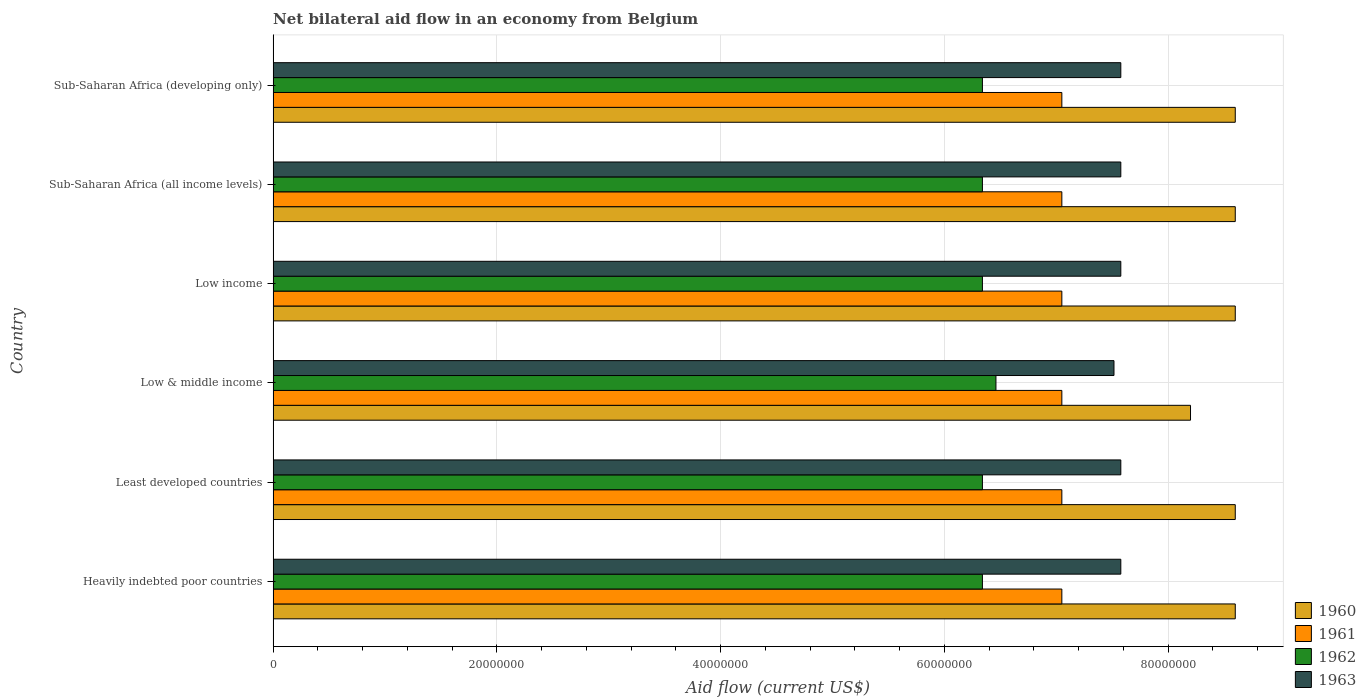How many groups of bars are there?
Your response must be concise. 6. Are the number of bars per tick equal to the number of legend labels?
Your answer should be very brief. Yes. How many bars are there on the 1st tick from the top?
Provide a succinct answer. 4. How many bars are there on the 2nd tick from the bottom?
Provide a succinct answer. 4. What is the label of the 1st group of bars from the top?
Provide a succinct answer. Sub-Saharan Africa (developing only). In how many cases, is the number of bars for a given country not equal to the number of legend labels?
Make the answer very short. 0. What is the net bilateral aid flow in 1960 in Low & middle income?
Your answer should be very brief. 8.20e+07. Across all countries, what is the maximum net bilateral aid flow in 1961?
Provide a succinct answer. 7.05e+07. Across all countries, what is the minimum net bilateral aid flow in 1960?
Offer a very short reply. 8.20e+07. In which country was the net bilateral aid flow in 1963 maximum?
Your answer should be compact. Heavily indebted poor countries. In which country was the net bilateral aid flow in 1961 minimum?
Your response must be concise. Heavily indebted poor countries. What is the total net bilateral aid flow in 1960 in the graph?
Provide a short and direct response. 5.12e+08. What is the difference between the net bilateral aid flow in 1961 in Heavily indebted poor countries and the net bilateral aid flow in 1963 in Least developed countries?
Keep it short and to the point. -5.27e+06. What is the average net bilateral aid flow in 1962 per country?
Offer a terse response. 6.36e+07. What is the difference between the net bilateral aid flow in 1962 and net bilateral aid flow in 1960 in Heavily indebted poor countries?
Provide a short and direct response. -2.26e+07. What is the difference between the highest and the lowest net bilateral aid flow in 1961?
Your response must be concise. 0. Is the sum of the net bilateral aid flow in 1962 in Least developed countries and Sub-Saharan Africa (developing only) greater than the maximum net bilateral aid flow in 1960 across all countries?
Your answer should be very brief. Yes. What does the 4th bar from the bottom in Low income represents?
Your answer should be very brief. 1963. Is it the case that in every country, the sum of the net bilateral aid flow in 1961 and net bilateral aid flow in 1962 is greater than the net bilateral aid flow in 1963?
Offer a very short reply. Yes. How many bars are there?
Your answer should be very brief. 24. How many countries are there in the graph?
Provide a short and direct response. 6. Does the graph contain any zero values?
Offer a terse response. No. How many legend labels are there?
Make the answer very short. 4. How are the legend labels stacked?
Your answer should be very brief. Vertical. What is the title of the graph?
Offer a terse response. Net bilateral aid flow in an economy from Belgium. Does "1967" appear as one of the legend labels in the graph?
Your answer should be compact. No. What is the label or title of the Y-axis?
Offer a terse response. Country. What is the Aid flow (current US$) in 1960 in Heavily indebted poor countries?
Your answer should be compact. 8.60e+07. What is the Aid flow (current US$) of 1961 in Heavily indebted poor countries?
Offer a terse response. 7.05e+07. What is the Aid flow (current US$) in 1962 in Heavily indebted poor countries?
Offer a very short reply. 6.34e+07. What is the Aid flow (current US$) of 1963 in Heavily indebted poor countries?
Provide a succinct answer. 7.58e+07. What is the Aid flow (current US$) in 1960 in Least developed countries?
Your answer should be compact. 8.60e+07. What is the Aid flow (current US$) of 1961 in Least developed countries?
Provide a succinct answer. 7.05e+07. What is the Aid flow (current US$) in 1962 in Least developed countries?
Ensure brevity in your answer.  6.34e+07. What is the Aid flow (current US$) in 1963 in Least developed countries?
Your answer should be very brief. 7.58e+07. What is the Aid flow (current US$) in 1960 in Low & middle income?
Ensure brevity in your answer.  8.20e+07. What is the Aid flow (current US$) of 1961 in Low & middle income?
Offer a very short reply. 7.05e+07. What is the Aid flow (current US$) of 1962 in Low & middle income?
Your response must be concise. 6.46e+07. What is the Aid flow (current US$) in 1963 in Low & middle income?
Offer a terse response. 7.52e+07. What is the Aid flow (current US$) of 1960 in Low income?
Make the answer very short. 8.60e+07. What is the Aid flow (current US$) of 1961 in Low income?
Make the answer very short. 7.05e+07. What is the Aid flow (current US$) of 1962 in Low income?
Ensure brevity in your answer.  6.34e+07. What is the Aid flow (current US$) in 1963 in Low income?
Give a very brief answer. 7.58e+07. What is the Aid flow (current US$) in 1960 in Sub-Saharan Africa (all income levels)?
Your answer should be compact. 8.60e+07. What is the Aid flow (current US$) of 1961 in Sub-Saharan Africa (all income levels)?
Offer a very short reply. 7.05e+07. What is the Aid flow (current US$) of 1962 in Sub-Saharan Africa (all income levels)?
Your answer should be very brief. 6.34e+07. What is the Aid flow (current US$) of 1963 in Sub-Saharan Africa (all income levels)?
Provide a short and direct response. 7.58e+07. What is the Aid flow (current US$) of 1960 in Sub-Saharan Africa (developing only)?
Your answer should be compact. 8.60e+07. What is the Aid flow (current US$) in 1961 in Sub-Saharan Africa (developing only)?
Provide a succinct answer. 7.05e+07. What is the Aid flow (current US$) in 1962 in Sub-Saharan Africa (developing only)?
Your answer should be compact. 6.34e+07. What is the Aid flow (current US$) in 1963 in Sub-Saharan Africa (developing only)?
Offer a very short reply. 7.58e+07. Across all countries, what is the maximum Aid flow (current US$) of 1960?
Provide a succinct answer. 8.60e+07. Across all countries, what is the maximum Aid flow (current US$) in 1961?
Keep it short and to the point. 7.05e+07. Across all countries, what is the maximum Aid flow (current US$) in 1962?
Make the answer very short. 6.46e+07. Across all countries, what is the maximum Aid flow (current US$) in 1963?
Offer a terse response. 7.58e+07. Across all countries, what is the minimum Aid flow (current US$) in 1960?
Provide a short and direct response. 8.20e+07. Across all countries, what is the minimum Aid flow (current US$) in 1961?
Provide a succinct answer. 7.05e+07. Across all countries, what is the minimum Aid flow (current US$) in 1962?
Your response must be concise. 6.34e+07. Across all countries, what is the minimum Aid flow (current US$) of 1963?
Offer a terse response. 7.52e+07. What is the total Aid flow (current US$) in 1960 in the graph?
Your answer should be compact. 5.12e+08. What is the total Aid flow (current US$) of 1961 in the graph?
Give a very brief answer. 4.23e+08. What is the total Aid flow (current US$) in 1962 in the graph?
Provide a short and direct response. 3.82e+08. What is the total Aid flow (current US$) in 1963 in the graph?
Provide a short and direct response. 4.54e+08. What is the difference between the Aid flow (current US$) of 1960 in Heavily indebted poor countries and that in Least developed countries?
Offer a very short reply. 0. What is the difference between the Aid flow (current US$) in 1962 in Heavily indebted poor countries and that in Least developed countries?
Provide a short and direct response. 0. What is the difference between the Aid flow (current US$) of 1961 in Heavily indebted poor countries and that in Low & middle income?
Your answer should be compact. 0. What is the difference between the Aid flow (current US$) in 1962 in Heavily indebted poor countries and that in Low & middle income?
Ensure brevity in your answer.  -1.21e+06. What is the difference between the Aid flow (current US$) in 1960 in Heavily indebted poor countries and that in Low income?
Your answer should be compact. 0. What is the difference between the Aid flow (current US$) of 1960 in Heavily indebted poor countries and that in Sub-Saharan Africa (all income levels)?
Make the answer very short. 0. What is the difference between the Aid flow (current US$) in 1961 in Heavily indebted poor countries and that in Sub-Saharan Africa (all income levels)?
Your answer should be very brief. 0. What is the difference between the Aid flow (current US$) in 1960 in Heavily indebted poor countries and that in Sub-Saharan Africa (developing only)?
Give a very brief answer. 0. What is the difference between the Aid flow (current US$) of 1962 in Heavily indebted poor countries and that in Sub-Saharan Africa (developing only)?
Make the answer very short. 0. What is the difference between the Aid flow (current US$) in 1963 in Heavily indebted poor countries and that in Sub-Saharan Africa (developing only)?
Your response must be concise. 0. What is the difference between the Aid flow (current US$) of 1962 in Least developed countries and that in Low & middle income?
Provide a succinct answer. -1.21e+06. What is the difference between the Aid flow (current US$) in 1963 in Least developed countries and that in Low & middle income?
Provide a short and direct response. 6.10e+05. What is the difference between the Aid flow (current US$) in 1963 in Least developed countries and that in Low income?
Ensure brevity in your answer.  0. What is the difference between the Aid flow (current US$) in 1960 in Least developed countries and that in Sub-Saharan Africa (all income levels)?
Offer a terse response. 0. What is the difference between the Aid flow (current US$) in 1961 in Least developed countries and that in Sub-Saharan Africa (all income levels)?
Ensure brevity in your answer.  0. What is the difference between the Aid flow (current US$) of 1963 in Least developed countries and that in Sub-Saharan Africa (all income levels)?
Give a very brief answer. 0. What is the difference between the Aid flow (current US$) of 1961 in Least developed countries and that in Sub-Saharan Africa (developing only)?
Provide a succinct answer. 0. What is the difference between the Aid flow (current US$) in 1962 in Least developed countries and that in Sub-Saharan Africa (developing only)?
Provide a succinct answer. 0. What is the difference between the Aid flow (current US$) in 1963 in Least developed countries and that in Sub-Saharan Africa (developing only)?
Provide a short and direct response. 0. What is the difference between the Aid flow (current US$) in 1960 in Low & middle income and that in Low income?
Offer a terse response. -4.00e+06. What is the difference between the Aid flow (current US$) of 1961 in Low & middle income and that in Low income?
Keep it short and to the point. 0. What is the difference between the Aid flow (current US$) of 1962 in Low & middle income and that in Low income?
Offer a very short reply. 1.21e+06. What is the difference between the Aid flow (current US$) of 1963 in Low & middle income and that in Low income?
Offer a very short reply. -6.10e+05. What is the difference between the Aid flow (current US$) in 1960 in Low & middle income and that in Sub-Saharan Africa (all income levels)?
Provide a short and direct response. -4.00e+06. What is the difference between the Aid flow (current US$) in 1961 in Low & middle income and that in Sub-Saharan Africa (all income levels)?
Keep it short and to the point. 0. What is the difference between the Aid flow (current US$) in 1962 in Low & middle income and that in Sub-Saharan Africa (all income levels)?
Ensure brevity in your answer.  1.21e+06. What is the difference between the Aid flow (current US$) in 1963 in Low & middle income and that in Sub-Saharan Africa (all income levels)?
Your answer should be compact. -6.10e+05. What is the difference between the Aid flow (current US$) in 1960 in Low & middle income and that in Sub-Saharan Africa (developing only)?
Provide a succinct answer. -4.00e+06. What is the difference between the Aid flow (current US$) in 1961 in Low & middle income and that in Sub-Saharan Africa (developing only)?
Give a very brief answer. 0. What is the difference between the Aid flow (current US$) of 1962 in Low & middle income and that in Sub-Saharan Africa (developing only)?
Give a very brief answer. 1.21e+06. What is the difference between the Aid flow (current US$) in 1963 in Low & middle income and that in Sub-Saharan Africa (developing only)?
Provide a short and direct response. -6.10e+05. What is the difference between the Aid flow (current US$) of 1960 in Low income and that in Sub-Saharan Africa (all income levels)?
Provide a short and direct response. 0. What is the difference between the Aid flow (current US$) of 1961 in Low income and that in Sub-Saharan Africa (all income levels)?
Offer a very short reply. 0. What is the difference between the Aid flow (current US$) in 1961 in Low income and that in Sub-Saharan Africa (developing only)?
Ensure brevity in your answer.  0. What is the difference between the Aid flow (current US$) in 1962 in Low income and that in Sub-Saharan Africa (developing only)?
Make the answer very short. 0. What is the difference between the Aid flow (current US$) in 1963 in Low income and that in Sub-Saharan Africa (developing only)?
Your answer should be compact. 0. What is the difference between the Aid flow (current US$) in 1960 in Sub-Saharan Africa (all income levels) and that in Sub-Saharan Africa (developing only)?
Your answer should be compact. 0. What is the difference between the Aid flow (current US$) in 1961 in Sub-Saharan Africa (all income levels) and that in Sub-Saharan Africa (developing only)?
Provide a short and direct response. 0. What is the difference between the Aid flow (current US$) of 1963 in Sub-Saharan Africa (all income levels) and that in Sub-Saharan Africa (developing only)?
Your answer should be very brief. 0. What is the difference between the Aid flow (current US$) in 1960 in Heavily indebted poor countries and the Aid flow (current US$) in 1961 in Least developed countries?
Offer a very short reply. 1.55e+07. What is the difference between the Aid flow (current US$) in 1960 in Heavily indebted poor countries and the Aid flow (current US$) in 1962 in Least developed countries?
Offer a very short reply. 2.26e+07. What is the difference between the Aid flow (current US$) of 1960 in Heavily indebted poor countries and the Aid flow (current US$) of 1963 in Least developed countries?
Keep it short and to the point. 1.02e+07. What is the difference between the Aid flow (current US$) in 1961 in Heavily indebted poor countries and the Aid flow (current US$) in 1962 in Least developed countries?
Your answer should be very brief. 7.10e+06. What is the difference between the Aid flow (current US$) in 1961 in Heavily indebted poor countries and the Aid flow (current US$) in 1963 in Least developed countries?
Provide a succinct answer. -5.27e+06. What is the difference between the Aid flow (current US$) of 1962 in Heavily indebted poor countries and the Aid flow (current US$) of 1963 in Least developed countries?
Provide a short and direct response. -1.24e+07. What is the difference between the Aid flow (current US$) of 1960 in Heavily indebted poor countries and the Aid flow (current US$) of 1961 in Low & middle income?
Your answer should be very brief. 1.55e+07. What is the difference between the Aid flow (current US$) of 1960 in Heavily indebted poor countries and the Aid flow (current US$) of 1962 in Low & middle income?
Make the answer very short. 2.14e+07. What is the difference between the Aid flow (current US$) in 1960 in Heavily indebted poor countries and the Aid flow (current US$) in 1963 in Low & middle income?
Offer a terse response. 1.08e+07. What is the difference between the Aid flow (current US$) of 1961 in Heavily indebted poor countries and the Aid flow (current US$) of 1962 in Low & middle income?
Your answer should be compact. 5.89e+06. What is the difference between the Aid flow (current US$) in 1961 in Heavily indebted poor countries and the Aid flow (current US$) in 1963 in Low & middle income?
Make the answer very short. -4.66e+06. What is the difference between the Aid flow (current US$) of 1962 in Heavily indebted poor countries and the Aid flow (current US$) of 1963 in Low & middle income?
Your answer should be compact. -1.18e+07. What is the difference between the Aid flow (current US$) of 1960 in Heavily indebted poor countries and the Aid flow (current US$) of 1961 in Low income?
Offer a terse response. 1.55e+07. What is the difference between the Aid flow (current US$) in 1960 in Heavily indebted poor countries and the Aid flow (current US$) in 1962 in Low income?
Give a very brief answer. 2.26e+07. What is the difference between the Aid flow (current US$) of 1960 in Heavily indebted poor countries and the Aid flow (current US$) of 1963 in Low income?
Offer a terse response. 1.02e+07. What is the difference between the Aid flow (current US$) in 1961 in Heavily indebted poor countries and the Aid flow (current US$) in 1962 in Low income?
Make the answer very short. 7.10e+06. What is the difference between the Aid flow (current US$) of 1961 in Heavily indebted poor countries and the Aid flow (current US$) of 1963 in Low income?
Your answer should be very brief. -5.27e+06. What is the difference between the Aid flow (current US$) of 1962 in Heavily indebted poor countries and the Aid flow (current US$) of 1963 in Low income?
Keep it short and to the point. -1.24e+07. What is the difference between the Aid flow (current US$) in 1960 in Heavily indebted poor countries and the Aid flow (current US$) in 1961 in Sub-Saharan Africa (all income levels)?
Offer a very short reply. 1.55e+07. What is the difference between the Aid flow (current US$) of 1960 in Heavily indebted poor countries and the Aid flow (current US$) of 1962 in Sub-Saharan Africa (all income levels)?
Keep it short and to the point. 2.26e+07. What is the difference between the Aid flow (current US$) of 1960 in Heavily indebted poor countries and the Aid flow (current US$) of 1963 in Sub-Saharan Africa (all income levels)?
Ensure brevity in your answer.  1.02e+07. What is the difference between the Aid flow (current US$) of 1961 in Heavily indebted poor countries and the Aid flow (current US$) of 1962 in Sub-Saharan Africa (all income levels)?
Make the answer very short. 7.10e+06. What is the difference between the Aid flow (current US$) in 1961 in Heavily indebted poor countries and the Aid flow (current US$) in 1963 in Sub-Saharan Africa (all income levels)?
Give a very brief answer. -5.27e+06. What is the difference between the Aid flow (current US$) of 1962 in Heavily indebted poor countries and the Aid flow (current US$) of 1963 in Sub-Saharan Africa (all income levels)?
Your response must be concise. -1.24e+07. What is the difference between the Aid flow (current US$) of 1960 in Heavily indebted poor countries and the Aid flow (current US$) of 1961 in Sub-Saharan Africa (developing only)?
Make the answer very short. 1.55e+07. What is the difference between the Aid flow (current US$) of 1960 in Heavily indebted poor countries and the Aid flow (current US$) of 1962 in Sub-Saharan Africa (developing only)?
Your answer should be very brief. 2.26e+07. What is the difference between the Aid flow (current US$) in 1960 in Heavily indebted poor countries and the Aid flow (current US$) in 1963 in Sub-Saharan Africa (developing only)?
Make the answer very short. 1.02e+07. What is the difference between the Aid flow (current US$) of 1961 in Heavily indebted poor countries and the Aid flow (current US$) of 1962 in Sub-Saharan Africa (developing only)?
Your answer should be compact. 7.10e+06. What is the difference between the Aid flow (current US$) of 1961 in Heavily indebted poor countries and the Aid flow (current US$) of 1963 in Sub-Saharan Africa (developing only)?
Provide a succinct answer. -5.27e+06. What is the difference between the Aid flow (current US$) in 1962 in Heavily indebted poor countries and the Aid flow (current US$) in 1963 in Sub-Saharan Africa (developing only)?
Ensure brevity in your answer.  -1.24e+07. What is the difference between the Aid flow (current US$) of 1960 in Least developed countries and the Aid flow (current US$) of 1961 in Low & middle income?
Provide a succinct answer. 1.55e+07. What is the difference between the Aid flow (current US$) in 1960 in Least developed countries and the Aid flow (current US$) in 1962 in Low & middle income?
Ensure brevity in your answer.  2.14e+07. What is the difference between the Aid flow (current US$) of 1960 in Least developed countries and the Aid flow (current US$) of 1963 in Low & middle income?
Keep it short and to the point. 1.08e+07. What is the difference between the Aid flow (current US$) in 1961 in Least developed countries and the Aid flow (current US$) in 1962 in Low & middle income?
Offer a terse response. 5.89e+06. What is the difference between the Aid flow (current US$) in 1961 in Least developed countries and the Aid flow (current US$) in 1963 in Low & middle income?
Ensure brevity in your answer.  -4.66e+06. What is the difference between the Aid flow (current US$) of 1962 in Least developed countries and the Aid flow (current US$) of 1963 in Low & middle income?
Keep it short and to the point. -1.18e+07. What is the difference between the Aid flow (current US$) of 1960 in Least developed countries and the Aid flow (current US$) of 1961 in Low income?
Ensure brevity in your answer.  1.55e+07. What is the difference between the Aid flow (current US$) of 1960 in Least developed countries and the Aid flow (current US$) of 1962 in Low income?
Provide a short and direct response. 2.26e+07. What is the difference between the Aid flow (current US$) in 1960 in Least developed countries and the Aid flow (current US$) in 1963 in Low income?
Your response must be concise. 1.02e+07. What is the difference between the Aid flow (current US$) in 1961 in Least developed countries and the Aid flow (current US$) in 1962 in Low income?
Keep it short and to the point. 7.10e+06. What is the difference between the Aid flow (current US$) of 1961 in Least developed countries and the Aid flow (current US$) of 1963 in Low income?
Your response must be concise. -5.27e+06. What is the difference between the Aid flow (current US$) in 1962 in Least developed countries and the Aid flow (current US$) in 1963 in Low income?
Make the answer very short. -1.24e+07. What is the difference between the Aid flow (current US$) in 1960 in Least developed countries and the Aid flow (current US$) in 1961 in Sub-Saharan Africa (all income levels)?
Keep it short and to the point. 1.55e+07. What is the difference between the Aid flow (current US$) in 1960 in Least developed countries and the Aid flow (current US$) in 1962 in Sub-Saharan Africa (all income levels)?
Ensure brevity in your answer.  2.26e+07. What is the difference between the Aid flow (current US$) in 1960 in Least developed countries and the Aid flow (current US$) in 1963 in Sub-Saharan Africa (all income levels)?
Provide a succinct answer. 1.02e+07. What is the difference between the Aid flow (current US$) in 1961 in Least developed countries and the Aid flow (current US$) in 1962 in Sub-Saharan Africa (all income levels)?
Offer a very short reply. 7.10e+06. What is the difference between the Aid flow (current US$) of 1961 in Least developed countries and the Aid flow (current US$) of 1963 in Sub-Saharan Africa (all income levels)?
Offer a terse response. -5.27e+06. What is the difference between the Aid flow (current US$) in 1962 in Least developed countries and the Aid flow (current US$) in 1963 in Sub-Saharan Africa (all income levels)?
Offer a terse response. -1.24e+07. What is the difference between the Aid flow (current US$) of 1960 in Least developed countries and the Aid flow (current US$) of 1961 in Sub-Saharan Africa (developing only)?
Ensure brevity in your answer.  1.55e+07. What is the difference between the Aid flow (current US$) in 1960 in Least developed countries and the Aid flow (current US$) in 1962 in Sub-Saharan Africa (developing only)?
Your answer should be very brief. 2.26e+07. What is the difference between the Aid flow (current US$) in 1960 in Least developed countries and the Aid flow (current US$) in 1963 in Sub-Saharan Africa (developing only)?
Provide a succinct answer. 1.02e+07. What is the difference between the Aid flow (current US$) of 1961 in Least developed countries and the Aid flow (current US$) of 1962 in Sub-Saharan Africa (developing only)?
Provide a succinct answer. 7.10e+06. What is the difference between the Aid flow (current US$) in 1961 in Least developed countries and the Aid flow (current US$) in 1963 in Sub-Saharan Africa (developing only)?
Your response must be concise. -5.27e+06. What is the difference between the Aid flow (current US$) of 1962 in Least developed countries and the Aid flow (current US$) of 1963 in Sub-Saharan Africa (developing only)?
Provide a succinct answer. -1.24e+07. What is the difference between the Aid flow (current US$) of 1960 in Low & middle income and the Aid flow (current US$) of 1961 in Low income?
Make the answer very short. 1.15e+07. What is the difference between the Aid flow (current US$) in 1960 in Low & middle income and the Aid flow (current US$) in 1962 in Low income?
Provide a succinct answer. 1.86e+07. What is the difference between the Aid flow (current US$) in 1960 in Low & middle income and the Aid flow (current US$) in 1963 in Low income?
Your response must be concise. 6.23e+06. What is the difference between the Aid flow (current US$) of 1961 in Low & middle income and the Aid flow (current US$) of 1962 in Low income?
Ensure brevity in your answer.  7.10e+06. What is the difference between the Aid flow (current US$) of 1961 in Low & middle income and the Aid flow (current US$) of 1963 in Low income?
Provide a short and direct response. -5.27e+06. What is the difference between the Aid flow (current US$) of 1962 in Low & middle income and the Aid flow (current US$) of 1963 in Low income?
Make the answer very short. -1.12e+07. What is the difference between the Aid flow (current US$) of 1960 in Low & middle income and the Aid flow (current US$) of 1961 in Sub-Saharan Africa (all income levels)?
Provide a succinct answer. 1.15e+07. What is the difference between the Aid flow (current US$) of 1960 in Low & middle income and the Aid flow (current US$) of 1962 in Sub-Saharan Africa (all income levels)?
Your response must be concise. 1.86e+07. What is the difference between the Aid flow (current US$) in 1960 in Low & middle income and the Aid flow (current US$) in 1963 in Sub-Saharan Africa (all income levels)?
Give a very brief answer. 6.23e+06. What is the difference between the Aid flow (current US$) of 1961 in Low & middle income and the Aid flow (current US$) of 1962 in Sub-Saharan Africa (all income levels)?
Offer a very short reply. 7.10e+06. What is the difference between the Aid flow (current US$) in 1961 in Low & middle income and the Aid flow (current US$) in 1963 in Sub-Saharan Africa (all income levels)?
Your answer should be very brief. -5.27e+06. What is the difference between the Aid flow (current US$) in 1962 in Low & middle income and the Aid flow (current US$) in 1963 in Sub-Saharan Africa (all income levels)?
Your answer should be compact. -1.12e+07. What is the difference between the Aid flow (current US$) in 1960 in Low & middle income and the Aid flow (current US$) in 1961 in Sub-Saharan Africa (developing only)?
Provide a succinct answer. 1.15e+07. What is the difference between the Aid flow (current US$) in 1960 in Low & middle income and the Aid flow (current US$) in 1962 in Sub-Saharan Africa (developing only)?
Give a very brief answer. 1.86e+07. What is the difference between the Aid flow (current US$) in 1960 in Low & middle income and the Aid flow (current US$) in 1963 in Sub-Saharan Africa (developing only)?
Offer a very short reply. 6.23e+06. What is the difference between the Aid flow (current US$) in 1961 in Low & middle income and the Aid flow (current US$) in 1962 in Sub-Saharan Africa (developing only)?
Offer a terse response. 7.10e+06. What is the difference between the Aid flow (current US$) in 1961 in Low & middle income and the Aid flow (current US$) in 1963 in Sub-Saharan Africa (developing only)?
Your answer should be very brief. -5.27e+06. What is the difference between the Aid flow (current US$) of 1962 in Low & middle income and the Aid flow (current US$) of 1963 in Sub-Saharan Africa (developing only)?
Provide a short and direct response. -1.12e+07. What is the difference between the Aid flow (current US$) in 1960 in Low income and the Aid flow (current US$) in 1961 in Sub-Saharan Africa (all income levels)?
Your answer should be compact. 1.55e+07. What is the difference between the Aid flow (current US$) of 1960 in Low income and the Aid flow (current US$) of 1962 in Sub-Saharan Africa (all income levels)?
Offer a terse response. 2.26e+07. What is the difference between the Aid flow (current US$) in 1960 in Low income and the Aid flow (current US$) in 1963 in Sub-Saharan Africa (all income levels)?
Offer a terse response. 1.02e+07. What is the difference between the Aid flow (current US$) in 1961 in Low income and the Aid flow (current US$) in 1962 in Sub-Saharan Africa (all income levels)?
Offer a very short reply. 7.10e+06. What is the difference between the Aid flow (current US$) of 1961 in Low income and the Aid flow (current US$) of 1963 in Sub-Saharan Africa (all income levels)?
Give a very brief answer. -5.27e+06. What is the difference between the Aid flow (current US$) of 1962 in Low income and the Aid flow (current US$) of 1963 in Sub-Saharan Africa (all income levels)?
Your answer should be very brief. -1.24e+07. What is the difference between the Aid flow (current US$) in 1960 in Low income and the Aid flow (current US$) in 1961 in Sub-Saharan Africa (developing only)?
Give a very brief answer. 1.55e+07. What is the difference between the Aid flow (current US$) of 1960 in Low income and the Aid flow (current US$) of 1962 in Sub-Saharan Africa (developing only)?
Keep it short and to the point. 2.26e+07. What is the difference between the Aid flow (current US$) of 1960 in Low income and the Aid flow (current US$) of 1963 in Sub-Saharan Africa (developing only)?
Your answer should be compact. 1.02e+07. What is the difference between the Aid flow (current US$) of 1961 in Low income and the Aid flow (current US$) of 1962 in Sub-Saharan Africa (developing only)?
Offer a terse response. 7.10e+06. What is the difference between the Aid flow (current US$) of 1961 in Low income and the Aid flow (current US$) of 1963 in Sub-Saharan Africa (developing only)?
Ensure brevity in your answer.  -5.27e+06. What is the difference between the Aid flow (current US$) in 1962 in Low income and the Aid flow (current US$) in 1963 in Sub-Saharan Africa (developing only)?
Offer a terse response. -1.24e+07. What is the difference between the Aid flow (current US$) of 1960 in Sub-Saharan Africa (all income levels) and the Aid flow (current US$) of 1961 in Sub-Saharan Africa (developing only)?
Ensure brevity in your answer.  1.55e+07. What is the difference between the Aid flow (current US$) in 1960 in Sub-Saharan Africa (all income levels) and the Aid flow (current US$) in 1962 in Sub-Saharan Africa (developing only)?
Provide a short and direct response. 2.26e+07. What is the difference between the Aid flow (current US$) in 1960 in Sub-Saharan Africa (all income levels) and the Aid flow (current US$) in 1963 in Sub-Saharan Africa (developing only)?
Keep it short and to the point. 1.02e+07. What is the difference between the Aid flow (current US$) in 1961 in Sub-Saharan Africa (all income levels) and the Aid flow (current US$) in 1962 in Sub-Saharan Africa (developing only)?
Ensure brevity in your answer.  7.10e+06. What is the difference between the Aid flow (current US$) in 1961 in Sub-Saharan Africa (all income levels) and the Aid flow (current US$) in 1963 in Sub-Saharan Africa (developing only)?
Provide a succinct answer. -5.27e+06. What is the difference between the Aid flow (current US$) in 1962 in Sub-Saharan Africa (all income levels) and the Aid flow (current US$) in 1963 in Sub-Saharan Africa (developing only)?
Offer a very short reply. -1.24e+07. What is the average Aid flow (current US$) of 1960 per country?
Offer a very short reply. 8.53e+07. What is the average Aid flow (current US$) of 1961 per country?
Keep it short and to the point. 7.05e+07. What is the average Aid flow (current US$) of 1962 per country?
Give a very brief answer. 6.36e+07. What is the average Aid flow (current US$) in 1963 per country?
Ensure brevity in your answer.  7.57e+07. What is the difference between the Aid flow (current US$) in 1960 and Aid flow (current US$) in 1961 in Heavily indebted poor countries?
Provide a short and direct response. 1.55e+07. What is the difference between the Aid flow (current US$) in 1960 and Aid flow (current US$) in 1962 in Heavily indebted poor countries?
Your answer should be very brief. 2.26e+07. What is the difference between the Aid flow (current US$) in 1960 and Aid flow (current US$) in 1963 in Heavily indebted poor countries?
Ensure brevity in your answer.  1.02e+07. What is the difference between the Aid flow (current US$) in 1961 and Aid flow (current US$) in 1962 in Heavily indebted poor countries?
Give a very brief answer. 7.10e+06. What is the difference between the Aid flow (current US$) of 1961 and Aid flow (current US$) of 1963 in Heavily indebted poor countries?
Ensure brevity in your answer.  -5.27e+06. What is the difference between the Aid flow (current US$) of 1962 and Aid flow (current US$) of 1963 in Heavily indebted poor countries?
Offer a terse response. -1.24e+07. What is the difference between the Aid flow (current US$) in 1960 and Aid flow (current US$) in 1961 in Least developed countries?
Offer a very short reply. 1.55e+07. What is the difference between the Aid flow (current US$) in 1960 and Aid flow (current US$) in 1962 in Least developed countries?
Provide a short and direct response. 2.26e+07. What is the difference between the Aid flow (current US$) of 1960 and Aid flow (current US$) of 1963 in Least developed countries?
Make the answer very short. 1.02e+07. What is the difference between the Aid flow (current US$) in 1961 and Aid flow (current US$) in 1962 in Least developed countries?
Give a very brief answer. 7.10e+06. What is the difference between the Aid flow (current US$) of 1961 and Aid flow (current US$) of 1963 in Least developed countries?
Your response must be concise. -5.27e+06. What is the difference between the Aid flow (current US$) of 1962 and Aid flow (current US$) of 1963 in Least developed countries?
Provide a short and direct response. -1.24e+07. What is the difference between the Aid flow (current US$) of 1960 and Aid flow (current US$) of 1961 in Low & middle income?
Provide a short and direct response. 1.15e+07. What is the difference between the Aid flow (current US$) of 1960 and Aid flow (current US$) of 1962 in Low & middle income?
Your answer should be compact. 1.74e+07. What is the difference between the Aid flow (current US$) in 1960 and Aid flow (current US$) in 1963 in Low & middle income?
Offer a terse response. 6.84e+06. What is the difference between the Aid flow (current US$) of 1961 and Aid flow (current US$) of 1962 in Low & middle income?
Your answer should be very brief. 5.89e+06. What is the difference between the Aid flow (current US$) of 1961 and Aid flow (current US$) of 1963 in Low & middle income?
Your answer should be compact. -4.66e+06. What is the difference between the Aid flow (current US$) of 1962 and Aid flow (current US$) of 1963 in Low & middle income?
Provide a succinct answer. -1.06e+07. What is the difference between the Aid flow (current US$) of 1960 and Aid flow (current US$) of 1961 in Low income?
Provide a succinct answer. 1.55e+07. What is the difference between the Aid flow (current US$) in 1960 and Aid flow (current US$) in 1962 in Low income?
Provide a succinct answer. 2.26e+07. What is the difference between the Aid flow (current US$) of 1960 and Aid flow (current US$) of 1963 in Low income?
Provide a succinct answer. 1.02e+07. What is the difference between the Aid flow (current US$) in 1961 and Aid flow (current US$) in 1962 in Low income?
Make the answer very short. 7.10e+06. What is the difference between the Aid flow (current US$) in 1961 and Aid flow (current US$) in 1963 in Low income?
Make the answer very short. -5.27e+06. What is the difference between the Aid flow (current US$) of 1962 and Aid flow (current US$) of 1963 in Low income?
Your response must be concise. -1.24e+07. What is the difference between the Aid flow (current US$) of 1960 and Aid flow (current US$) of 1961 in Sub-Saharan Africa (all income levels)?
Your answer should be very brief. 1.55e+07. What is the difference between the Aid flow (current US$) of 1960 and Aid flow (current US$) of 1962 in Sub-Saharan Africa (all income levels)?
Make the answer very short. 2.26e+07. What is the difference between the Aid flow (current US$) of 1960 and Aid flow (current US$) of 1963 in Sub-Saharan Africa (all income levels)?
Provide a succinct answer. 1.02e+07. What is the difference between the Aid flow (current US$) in 1961 and Aid flow (current US$) in 1962 in Sub-Saharan Africa (all income levels)?
Offer a very short reply. 7.10e+06. What is the difference between the Aid flow (current US$) in 1961 and Aid flow (current US$) in 1963 in Sub-Saharan Africa (all income levels)?
Provide a short and direct response. -5.27e+06. What is the difference between the Aid flow (current US$) in 1962 and Aid flow (current US$) in 1963 in Sub-Saharan Africa (all income levels)?
Your response must be concise. -1.24e+07. What is the difference between the Aid flow (current US$) in 1960 and Aid flow (current US$) in 1961 in Sub-Saharan Africa (developing only)?
Give a very brief answer. 1.55e+07. What is the difference between the Aid flow (current US$) of 1960 and Aid flow (current US$) of 1962 in Sub-Saharan Africa (developing only)?
Provide a succinct answer. 2.26e+07. What is the difference between the Aid flow (current US$) of 1960 and Aid flow (current US$) of 1963 in Sub-Saharan Africa (developing only)?
Provide a succinct answer. 1.02e+07. What is the difference between the Aid flow (current US$) of 1961 and Aid flow (current US$) of 1962 in Sub-Saharan Africa (developing only)?
Your answer should be compact. 7.10e+06. What is the difference between the Aid flow (current US$) in 1961 and Aid flow (current US$) in 1963 in Sub-Saharan Africa (developing only)?
Give a very brief answer. -5.27e+06. What is the difference between the Aid flow (current US$) of 1962 and Aid flow (current US$) of 1963 in Sub-Saharan Africa (developing only)?
Make the answer very short. -1.24e+07. What is the ratio of the Aid flow (current US$) of 1960 in Heavily indebted poor countries to that in Least developed countries?
Offer a very short reply. 1. What is the ratio of the Aid flow (current US$) in 1960 in Heavily indebted poor countries to that in Low & middle income?
Give a very brief answer. 1.05. What is the ratio of the Aid flow (current US$) in 1961 in Heavily indebted poor countries to that in Low & middle income?
Keep it short and to the point. 1. What is the ratio of the Aid flow (current US$) of 1962 in Heavily indebted poor countries to that in Low & middle income?
Offer a very short reply. 0.98. What is the ratio of the Aid flow (current US$) in 1963 in Heavily indebted poor countries to that in Low & middle income?
Ensure brevity in your answer.  1.01. What is the ratio of the Aid flow (current US$) in 1960 in Heavily indebted poor countries to that in Low income?
Your answer should be compact. 1. What is the ratio of the Aid flow (current US$) of 1962 in Heavily indebted poor countries to that in Low income?
Make the answer very short. 1. What is the ratio of the Aid flow (current US$) in 1963 in Heavily indebted poor countries to that in Low income?
Your answer should be compact. 1. What is the ratio of the Aid flow (current US$) in 1960 in Heavily indebted poor countries to that in Sub-Saharan Africa (all income levels)?
Your answer should be compact. 1. What is the ratio of the Aid flow (current US$) in 1963 in Heavily indebted poor countries to that in Sub-Saharan Africa (all income levels)?
Provide a short and direct response. 1. What is the ratio of the Aid flow (current US$) in 1961 in Heavily indebted poor countries to that in Sub-Saharan Africa (developing only)?
Ensure brevity in your answer.  1. What is the ratio of the Aid flow (current US$) of 1962 in Heavily indebted poor countries to that in Sub-Saharan Africa (developing only)?
Your response must be concise. 1. What is the ratio of the Aid flow (current US$) in 1960 in Least developed countries to that in Low & middle income?
Your answer should be compact. 1.05. What is the ratio of the Aid flow (current US$) in 1962 in Least developed countries to that in Low & middle income?
Give a very brief answer. 0.98. What is the ratio of the Aid flow (current US$) of 1963 in Least developed countries to that in Low & middle income?
Provide a short and direct response. 1.01. What is the ratio of the Aid flow (current US$) in 1960 in Least developed countries to that in Low income?
Make the answer very short. 1. What is the ratio of the Aid flow (current US$) in 1962 in Least developed countries to that in Low income?
Give a very brief answer. 1. What is the ratio of the Aid flow (current US$) in 1963 in Least developed countries to that in Low income?
Offer a very short reply. 1. What is the ratio of the Aid flow (current US$) of 1960 in Least developed countries to that in Sub-Saharan Africa (developing only)?
Your answer should be compact. 1. What is the ratio of the Aid flow (current US$) in 1963 in Least developed countries to that in Sub-Saharan Africa (developing only)?
Provide a short and direct response. 1. What is the ratio of the Aid flow (current US$) of 1960 in Low & middle income to that in Low income?
Offer a very short reply. 0.95. What is the ratio of the Aid flow (current US$) in 1962 in Low & middle income to that in Low income?
Provide a succinct answer. 1.02. What is the ratio of the Aid flow (current US$) in 1963 in Low & middle income to that in Low income?
Provide a short and direct response. 0.99. What is the ratio of the Aid flow (current US$) in 1960 in Low & middle income to that in Sub-Saharan Africa (all income levels)?
Make the answer very short. 0.95. What is the ratio of the Aid flow (current US$) in 1961 in Low & middle income to that in Sub-Saharan Africa (all income levels)?
Keep it short and to the point. 1. What is the ratio of the Aid flow (current US$) of 1962 in Low & middle income to that in Sub-Saharan Africa (all income levels)?
Provide a succinct answer. 1.02. What is the ratio of the Aid flow (current US$) of 1960 in Low & middle income to that in Sub-Saharan Africa (developing only)?
Provide a short and direct response. 0.95. What is the ratio of the Aid flow (current US$) in 1961 in Low & middle income to that in Sub-Saharan Africa (developing only)?
Ensure brevity in your answer.  1. What is the ratio of the Aid flow (current US$) of 1962 in Low & middle income to that in Sub-Saharan Africa (developing only)?
Keep it short and to the point. 1.02. What is the ratio of the Aid flow (current US$) of 1960 in Low income to that in Sub-Saharan Africa (all income levels)?
Make the answer very short. 1. What is the ratio of the Aid flow (current US$) of 1962 in Low income to that in Sub-Saharan Africa (all income levels)?
Give a very brief answer. 1. What is the ratio of the Aid flow (current US$) in 1960 in Low income to that in Sub-Saharan Africa (developing only)?
Provide a succinct answer. 1. What is the ratio of the Aid flow (current US$) of 1961 in Low income to that in Sub-Saharan Africa (developing only)?
Offer a terse response. 1. What is the ratio of the Aid flow (current US$) of 1962 in Low income to that in Sub-Saharan Africa (developing only)?
Offer a terse response. 1. What is the ratio of the Aid flow (current US$) in 1960 in Sub-Saharan Africa (all income levels) to that in Sub-Saharan Africa (developing only)?
Your response must be concise. 1. What is the ratio of the Aid flow (current US$) in 1963 in Sub-Saharan Africa (all income levels) to that in Sub-Saharan Africa (developing only)?
Give a very brief answer. 1. What is the difference between the highest and the second highest Aid flow (current US$) of 1961?
Make the answer very short. 0. What is the difference between the highest and the second highest Aid flow (current US$) of 1962?
Offer a terse response. 1.21e+06. What is the difference between the highest and the lowest Aid flow (current US$) in 1960?
Offer a very short reply. 4.00e+06. What is the difference between the highest and the lowest Aid flow (current US$) in 1962?
Offer a terse response. 1.21e+06. 